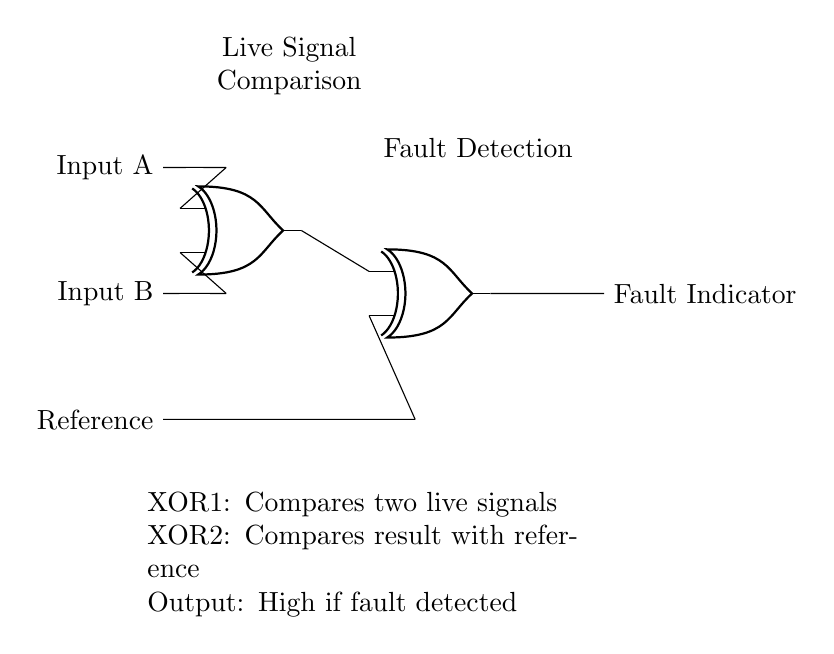What are the inputs to the first XOR gate? The inputs to the first XOR gate are Input A and Input B, which are directly connected to its input terminals.
Answer: Input A, Input B What signal is compared to the result of the first XOR gate? The output of the first XOR gate is compared to a reference signal at the second XOR gate, which is indicated by the connection lines in the diagram.
Answer: Reference signal What does the output of the circuit represent? The output of the circuit (Fault Indicator) represents whether a fault is detected, with a high signal indicating a fault, as shown by the output terminal of the last XOR gate.
Answer: Fault Indicator How many XOR gates are present in the circuit? There are two XOR gates in the circuit, which are clearly indicated by their symbols in the design.
Answer: Two What is the role of the second XOR gate? The second XOR gate compares the output of the first XOR gate with a reference signal to determine if there’s a discrepancy, hence playing a vital role in fault detection.
Answer: Fault detection If both Input A and Input B are the same, what will the output be? If both input signals are the same, the first XOR gate will output a low signal, which when compared with the reference signal will halt the indication of a fault, leading to a low output from the second XOR gate as well.
Answer: Low 